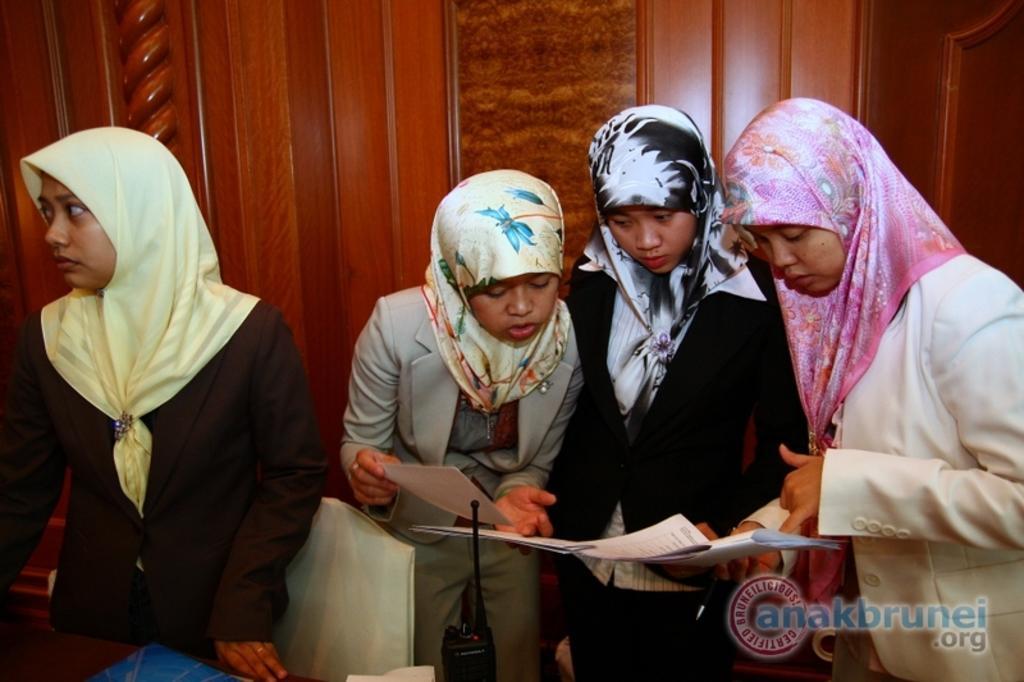How would you summarize this image in a sentence or two? In this picture we can see there are four persons standing and among them three persons are holding the papers. In front of the people, there are some objects and a walkie talkie. Behind the people, there is a wooden wall. In the bottom right corner of the image, there is a watermark. 